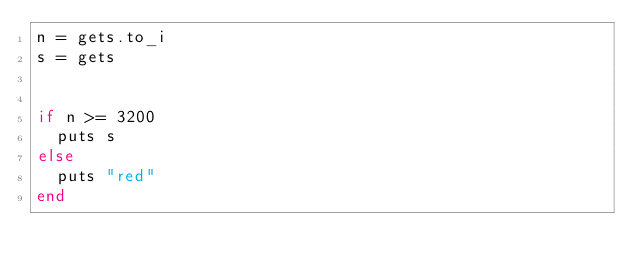Convert code to text. <code><loc_0><loc_0><loc_500><loc_500><_Ruby_>n = gets.to_i
s = gets


if n >= 3200
  puts s
else
  puts "red"
end</code> 